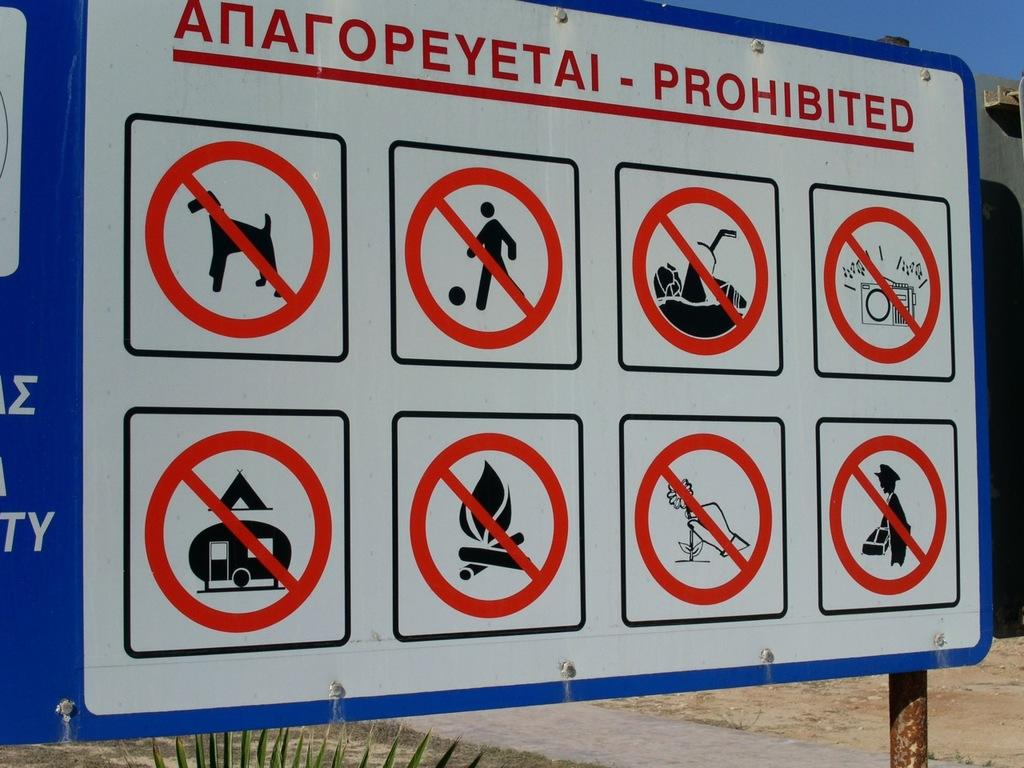Provide a one-sentence caption for the provided image. The sign displays all the prohibited behavior at the beach. 